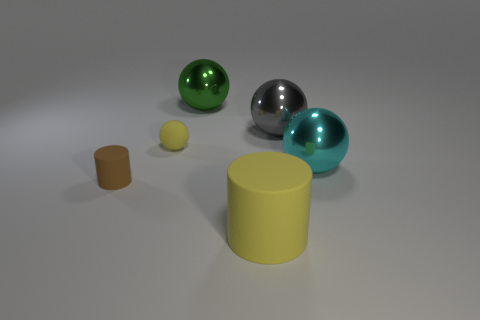There is a rubber object that is the same size as the green shiny object; what color is it?
Provide a succinct answer. Yellow. What is the cylinder that is in front of the brown cylinder made of?
Your response must be concise. Rubber. There is a metallic object that is left of the large matte cylinder; does it have the same shape as the yellow rubber object left of the green shiny thing?
Provide a short and direct response. Yes. Are there an equal number of big cyan things to the right of the large cyan metal sphere and small blue metal balls?
Your response must be concise. Yes. How many small cyan objects have the same material as the large cylinder?
Give a very brief answer. 0. What color is the big thing that is made of the same material as the tiny yellow thing?
Keep it short and to the point. Yellow. There is a brown thing; is its size the same as the object that is behind the big gray shiny object?
Give a very brief answer. No. There is a big matte thing; what shape is it?
Make the answer very short. Cylinder. What number of big rubber things are the same color as the small rubber sphere?
Provide a short and direct response. 1. There is another matte thing that is the same shape as the large rubber thing; what is its color?
Your response must be concise. Brown. 